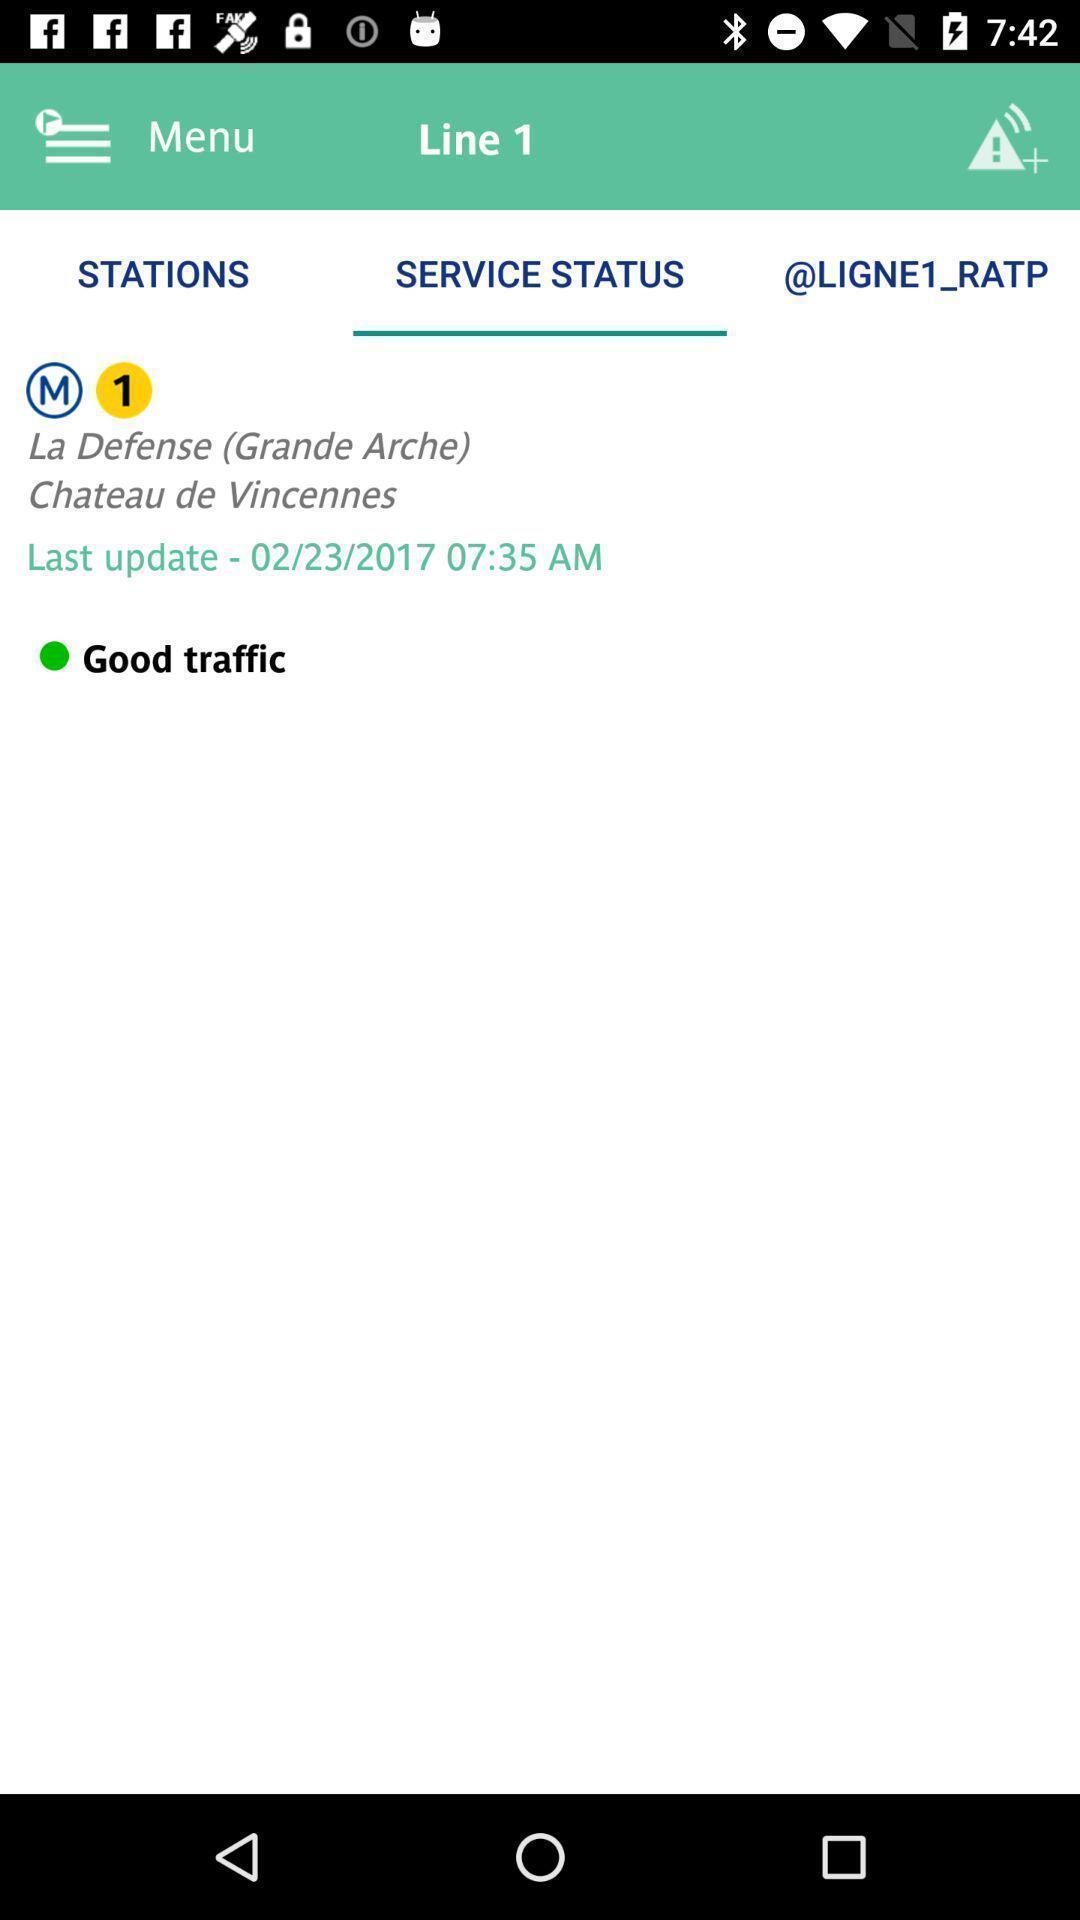Give me a narrative description of this picture. Page showing info in a transit tracking app. 